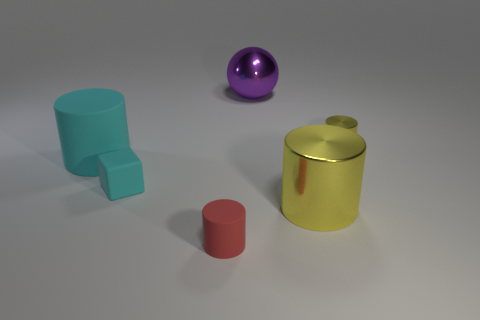How many objects are big purple things or large things in front of the matte block?
Provide a succinct answer. 2. Is the number of rubber cylinders that are left of the tiny cube greater than the number of small rubber blocks right of the big yellow thing?
Give a very brief answer. Yes. There is a small cylinder that is behind the tiny matte object that is in front of the cyan object that is on the right side of the cyan cylinder; what is it made of?
Keep it short and to the point. Metal. There is another large thing that is the same material as the purple object; what is its shape?
Give a very brief answer. Cylinder. There is a big cylinder that is on the left side of the red thing; are there any big purple spheres in front of it?
Keep it short and to the point. No. What is the size of the red thing?
Make the answer very short. Small. What number of things are small yellow cylinders or big cyan things?
Your response must be concise. 2. Is the large cylinder in front of the cube made of the same material as the thing that is behind the small yellow shiny object?
Keep it short and to the point. Yes. There is a cylinder that is made of the same material as the red object; what color is it?
Offer a terse response. Cyan. What number of yellow shiny cylinders are the same size as the cyan cylinder?
Your answer should be very brief. 1. 